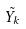Convert formula to latex. <formula><loc_0><loc_0><loc_500><loc_500>\tilde { Y _ { k } }</formula> 